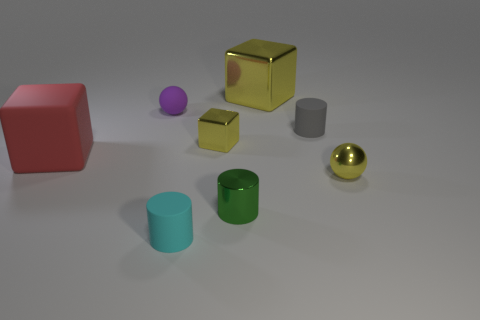Subtract all rubber cylinders. How many cylinders are left? 1 Subtract all cyan cylinders. How many cylinders are left? 2 Add 1 big things. How many objects exist? 9 Subtract 1 blocks. How many blocks are left? 2 Subtract all blocks. How many objects are left? 5 Subtract all blue cylinders. How many yellow cubes are left? 2 Subtract all red blocks. Subtract all small yellow spheres. How many objects are left? 6 Add 1 large yellow blocks. How many large yellow blocks are left? 2 Add 1 big metal cubes. How many big metal cubes exist? 2 Subtract 0 brown spheres. How many objects are left? 8 